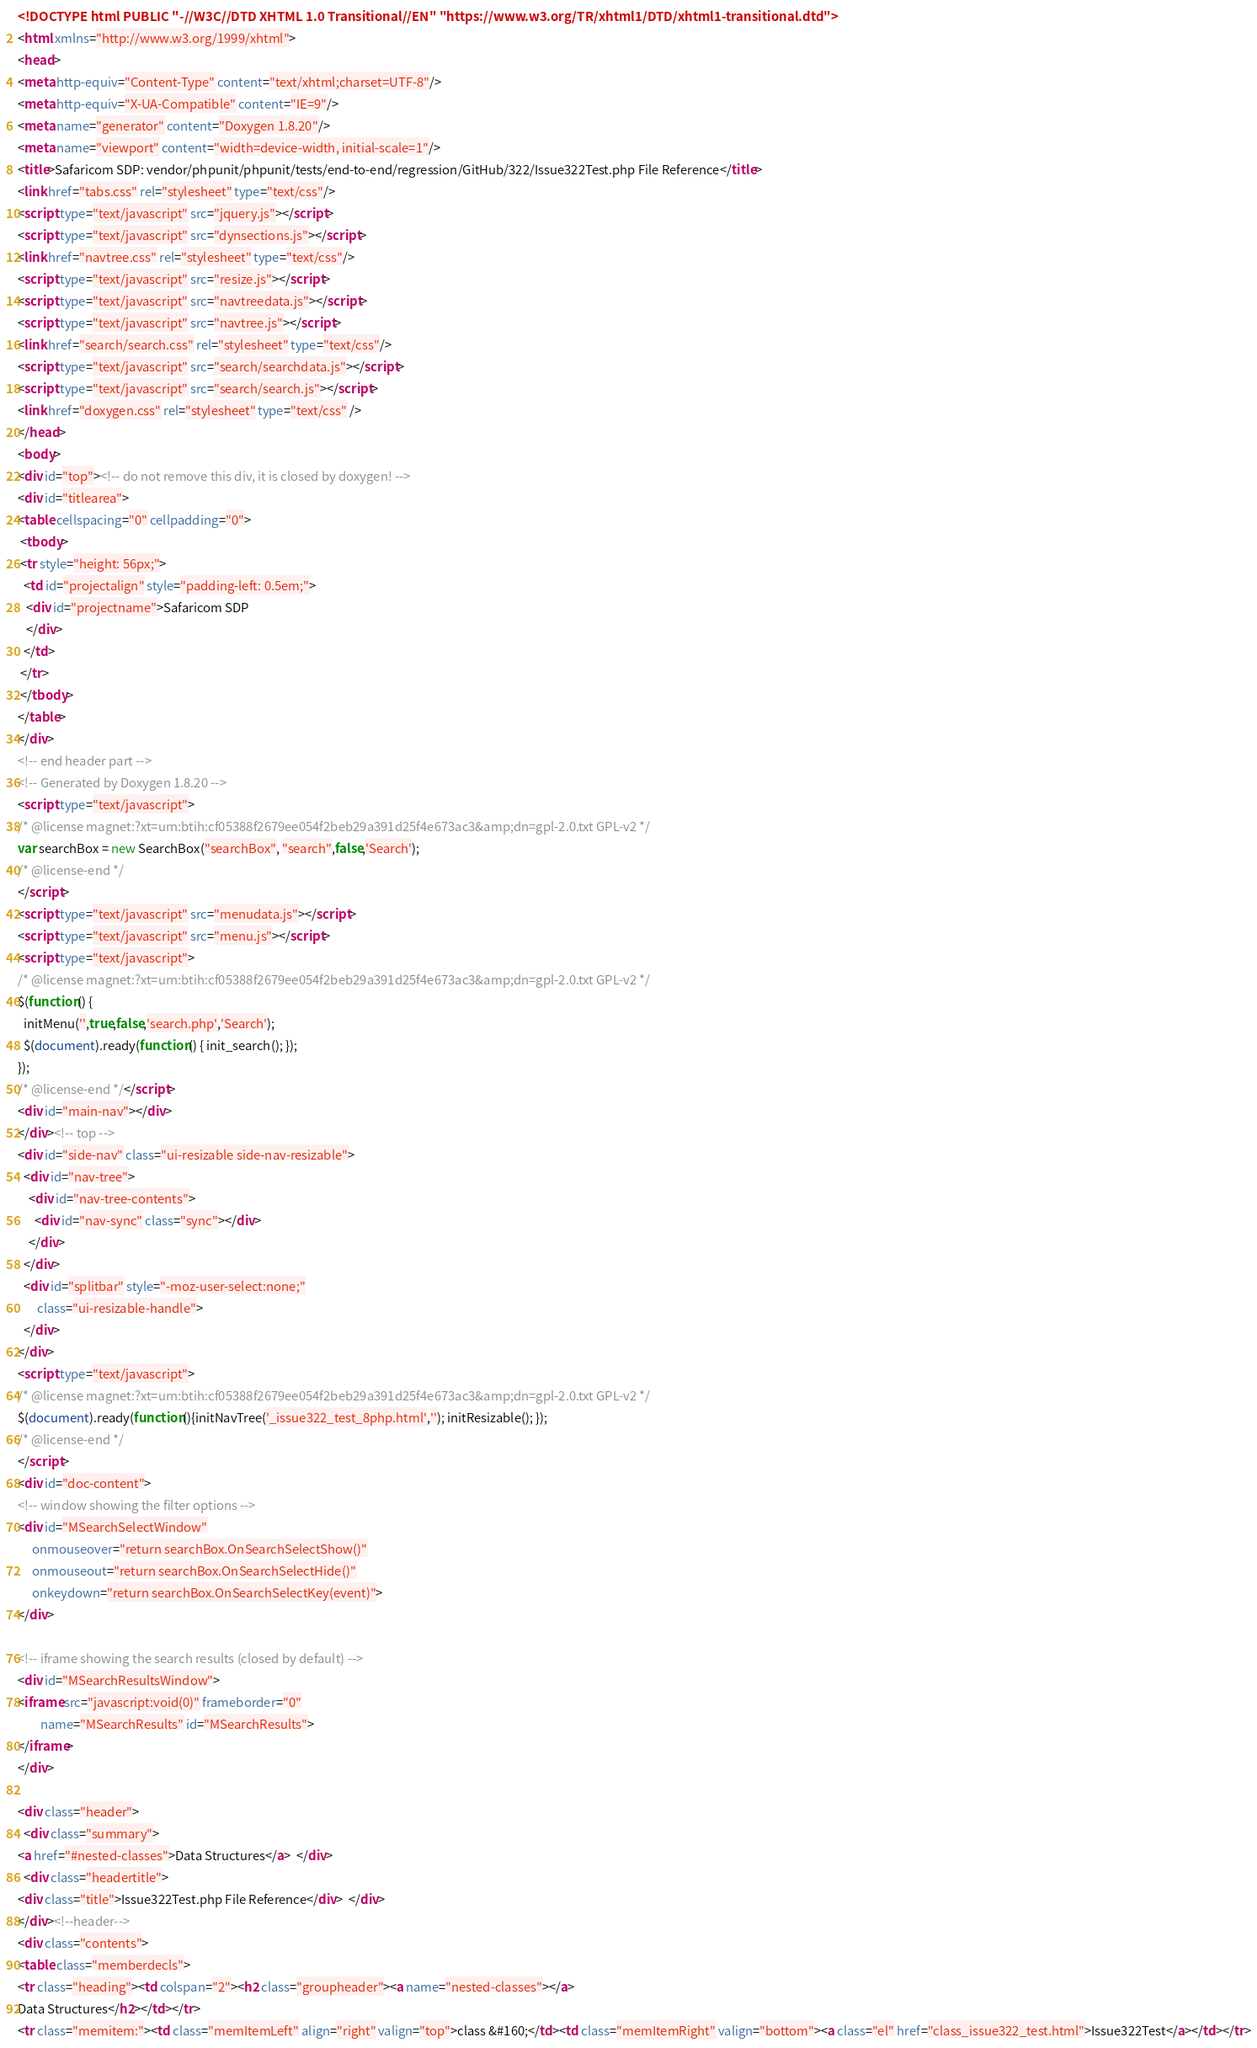<code> <loc_0><loc_0><loc_500><loc_500><_HTML_><!DOCTYPE html PUBLIC "-//W3C//DTD XHTML 1.0 Transitional//EN" "https://www.w3.org/TR/xhtml1/DTD/xhtml1-transitional.dtd">
<html xmlns="http://www.w3.org/1999/xhtml">
<head>
<meta http-equiv="Content-Type" content="text/xhtml;charset=UTF-8"/>
<meta http-equiv="X-UA-Compatible" content="IE=9"/>
<meta name="generator" content="Doxygen 1.8.20"/>
<meta name="viewport" content="width=device-width, initial-scale=1"/>
<title>Safaricom SDP: vendor/phpunit/phpunit/tests/end-to-end/regression/GitHub/322/Issue322Test.php File Reference</title>
<link href="tabs.css" rel="stylesheet" type="text/css"/>
<script type="text/javascript" src="jquery.js"></script>
<script type="text/javascript" src="dynsections.js"></script>
<link href="navtree.css" rel="stylesheet" type="text/css"/>
<script type="text/javascript" src="resize.js"></script>
<script type="text/javascript" src="navtreedata.js"></script>
<script type="text/javascript" src="navtree.js"></script>
<link href="search/search.css" rel="stylesheet" type="text/css"/>
<script type="text/javascript" src="search/searchdata.js"></script>
<script type="text/javascript" src="search/search.js"></script>
<link href="doxygen.css" rel="stylesheet" type="text/css" />
</head>
<body>
<div id="top"><!-- do not remove this div, it is closed by doxygen! -->
<div id="titlearea">
<table cellspacing="0" cellpadding="0">
 <tbody>
 <tr style="height: 56px;">
  <td id="projectalign" style="padding-left: 0.5em;">
   <div id="projectname">Safaricom SDP
   </div>
  </td>
 </tr>
 </tbody>
</table>
</div>
<!-- end header part -->
<!-- Generated by Doxygen 1.8.20 -->
<script type="text/javascript">
/* @license magnet:?xt=urn:btih:cf05388f2679ee054f2beb29a391d25f4e673ac3&amp;dn=gpl-2.0.txt GPL-v2 */
var searchBox = new SearchBox("searchBox", "search",false,'Search');
/* @license-end */
</script>
<script type="text/javascript" src="menudata.js"></script>
<script type="text/javascript" src="menu.js"></script>
<script type="text/javascript">
/* @license magnet:?xt=urn:btih:cf05388f2679ee054f2beb29a391d25f4e673ac3&amp;dn=gpl-2.0.txt GPL-v2 */
$(function() {
  initMenu('',true,false,'search.php','Search');
  $(document).ready(function() { init_search(); });
});
/* @license-end */</script>
<div id="main-nav"></div>
</div><!-- top -->
<div id="side-nav" class="ui-resizable side-nav-resizable">
  <div id="nav-tree">
    <div id="nav-tree-contents">
      <div id="nav-sync" class="sync"></div>
    </div>
  </div>
  <div id="splitbar" style="-moz-user-select:none;" 
       class="ui-resizable-handle">
  </div>
</div>
<script type="text/javascript">
/* @license magnet:?xt=urn:btih:cf05388f2679ee054f2beb29a391d25f4e673ac3&amp;dn=gpl-2.0.txt GPL-v2 */
$(document).ready(function(){initNavTree('_issue322_test_8php.html',''); initResizable(); });
/* @license-end */
</script>
<div id="doc-content">
<!-- window showing the filter options -->
<div id="MSearchSelectWindow"
     onmouseover="return searchBox.OnSearchSelectShow()"
     onmouseout="return searchBox.OnSearchSelectHide()"
     onkeydown="return searchBox.OnSearchSelectKey(event)">
</div>

<!-- iframe showing the search results (closed by default) -->
<div id="MSearchResultsWindow">
<iframe src="javascript:void(0)" frameborder="0" 
        name="MSearchResults" id="MSearchResults">
</iframe>
</div>

<div class="header">
  <div class="summary">
<a href="#nested-classes">Data Structures</a>  </div>
  <div class="headertitle">
<div class="title">Issue322Test.php File Reference</div>  </div>
</div><!--header-->
<div class="contents">
<table class="memberdecls">
<tr class="heading"><td colspan="2"><h2 class="groupheader"><a name="nested-classes"></a>
Data Structures</h2></td></tr>
<tr class="memitem:"><td class="memItemLeft" align="right" valign="top">class &#160;</td><td class="memItemRight" valign="bottom"><a class="el" href="class_issue322_test.html">Issue322Test</a></td></tr></code> 